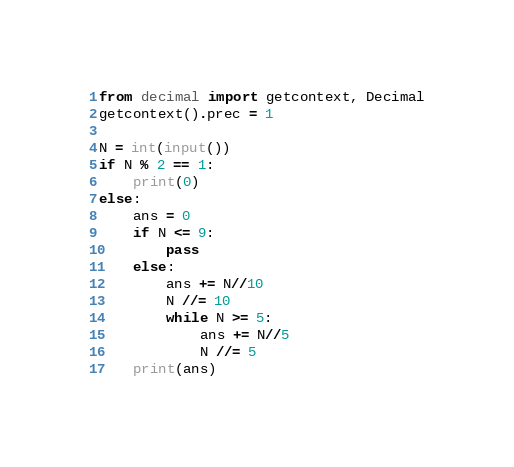<code> <loc_0><loc_0><loc_500><loc_500><_Python_>from decimal import getcontext, Decimal
getcontext().prec = 1

N = int(input())
if N % 2 == 1:
	print(0)
else:
	ans = 0
	if N <= 9:
		pass
	else:
		ans += N//10
		N //= 10
		while N >= 5:
			ans += N//5
			N //= 5
	print(ans)</code> 